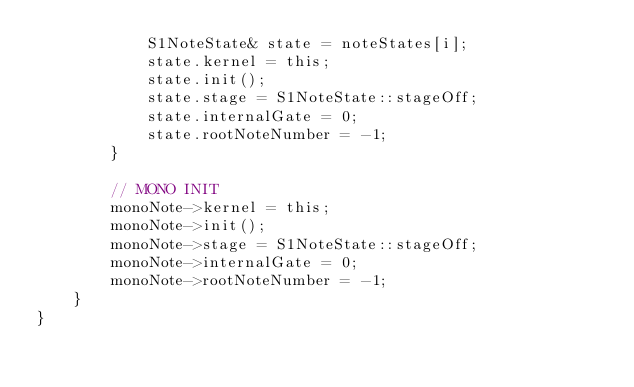<code> <loc_0><loc_0><loc_500><loc_500><_ObjectiveC_>            S1NoteState& state = noteStates[i];
            state.kernel = this;
            state.init();
            state.stage = S1NoteState::stageOff;
            state.internalGate = 0;
            state.rootNoteNumber = -1;
        }

        // MONO INIT
        monoNote->kernel = this;
        monoNote->init();
        monoNote->stage = S1NoteState::stageOff;
        monoNote->internalGate = 0;
        monoNote->rootNoteNumber = -1;
    }
}
</code> 